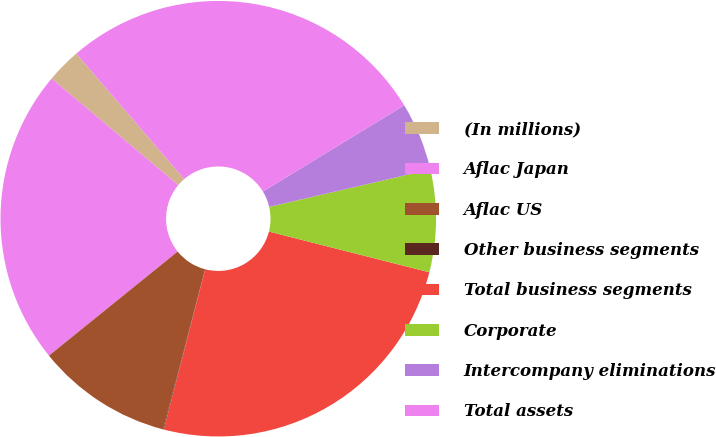<chart> <loc_0><loc_0><loc_500><loc_500><pie_chart><fcel>(In millions)<fcel>Aflac Japan<fcel>Aflac US<fcel>Other business segments<fcel>Total business segments<fcel>Corporate<fcel>Intercompany eliminations<fcel>Total assets<nl><fcel>2.57%<fcel>21.95%<fcel>10.1%<fcel>0.05%<fcel>25.07%<fcel>7.59%<fcel>5.08%<fcel>27.59%<nl></chart> 